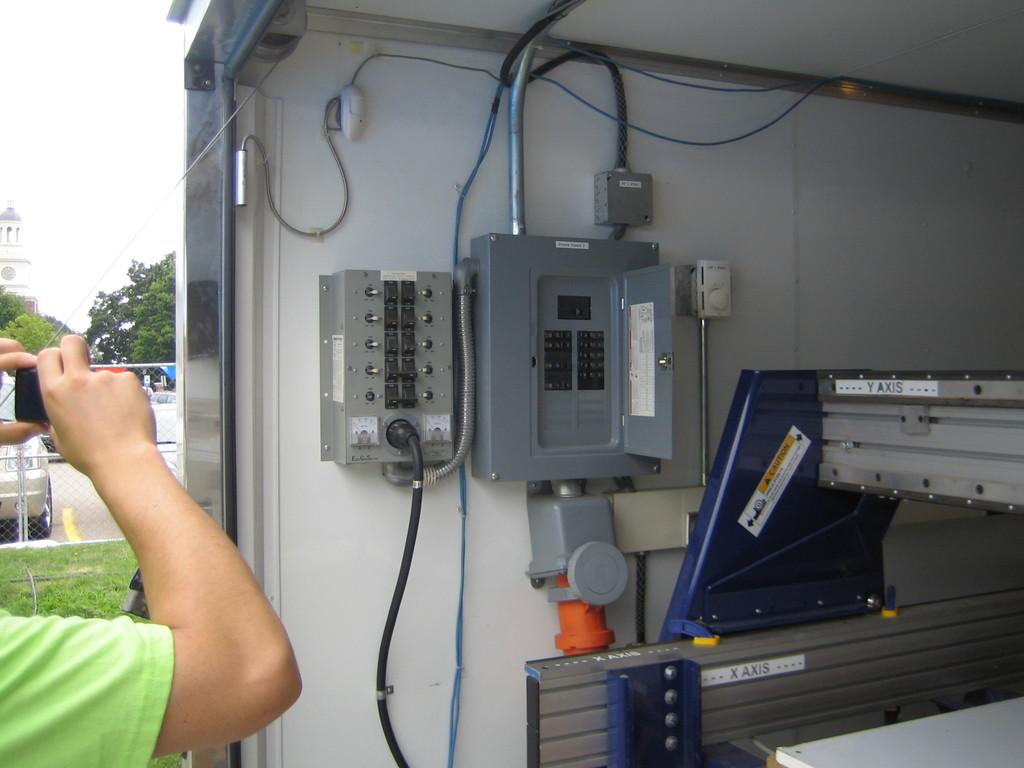What is located on the wall in the center of the image? There are electrical cabinets on the wall in the center of the image. What can be seen in the background of the image? There is a building, trees, a vehicle, a road, grass, a person, and sky visible in the background of the image. What type of pain is the person experiencing in the image? There is no indication of pain in the image; the person is simply visible in the background. 